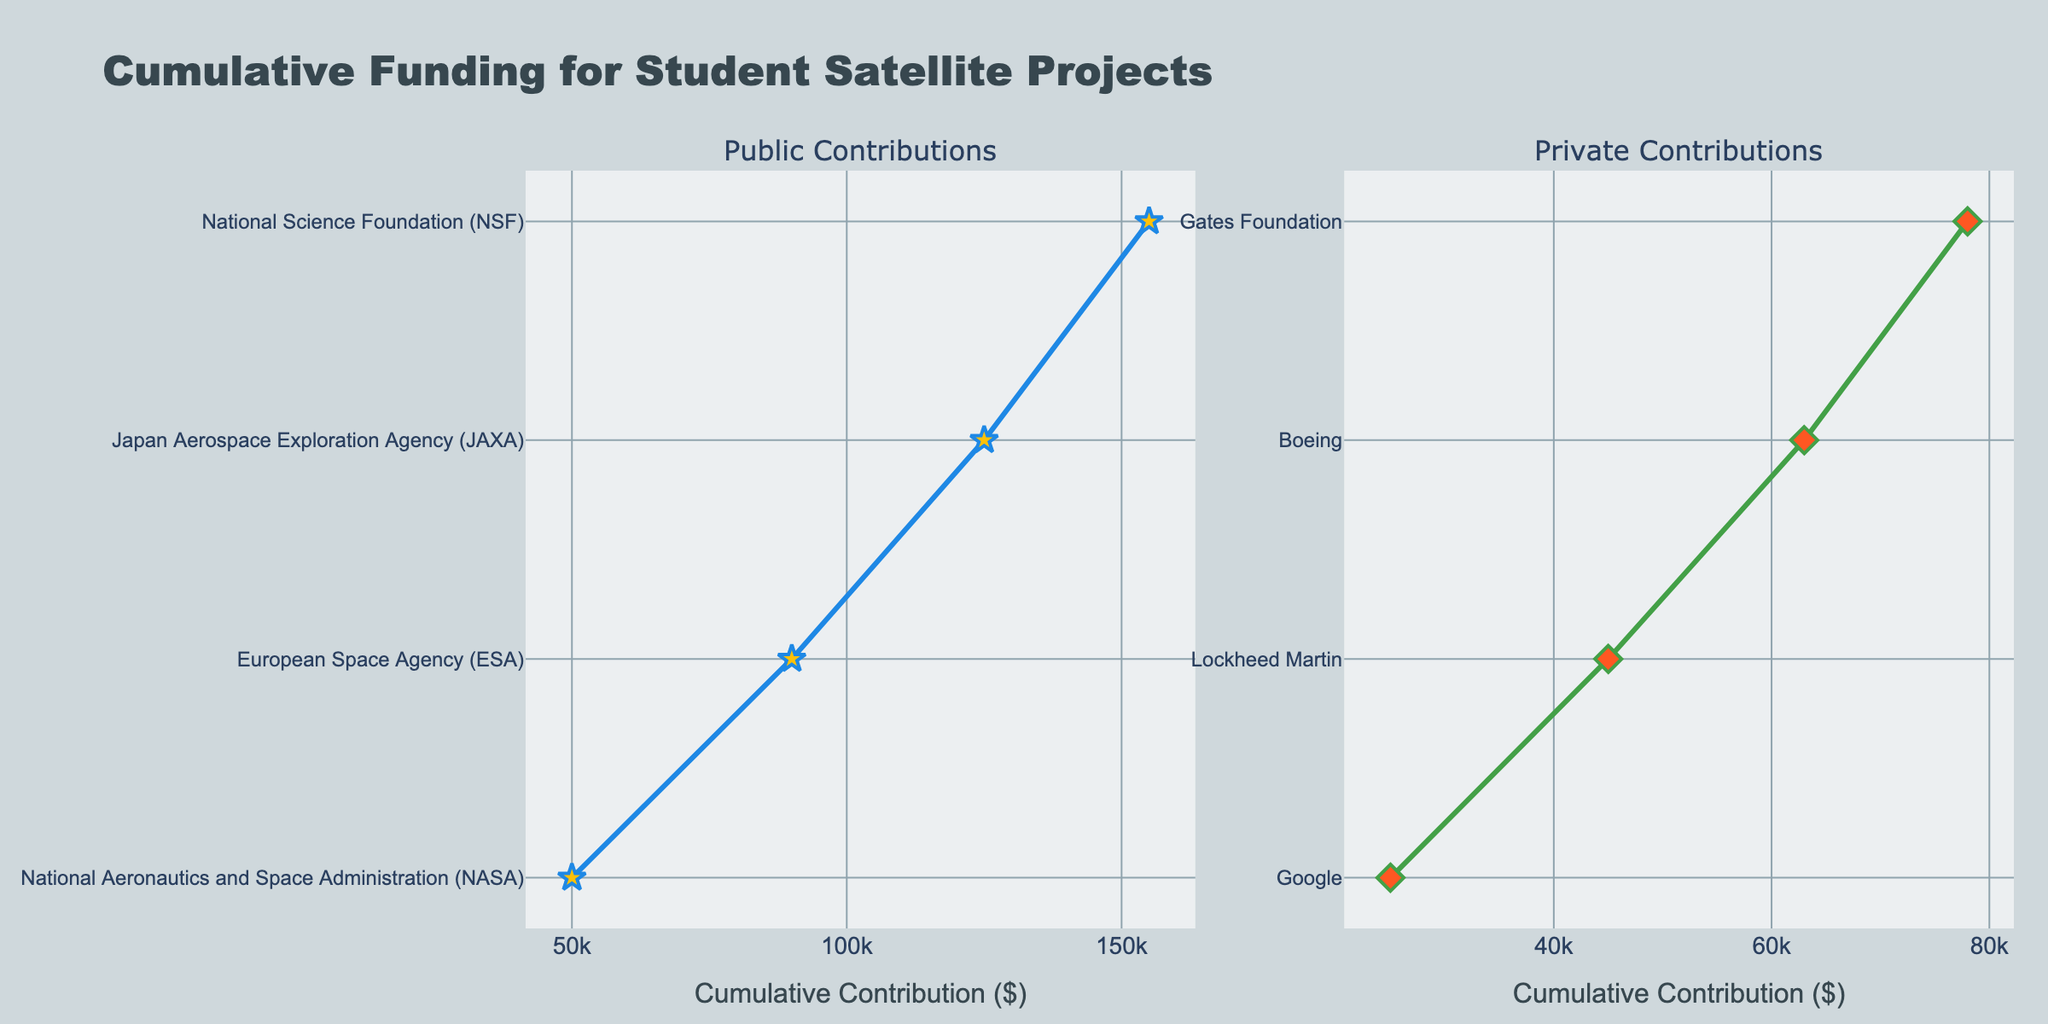What is the title of the figure? The title is located at the top of the plot and summarizes the content of the figure. In this case, it reads "Cumulative Funding for Student Satellite Projects".
Answer: Cumulative Funding for Student Satellite Projects What are the x-axis labels in the figure? The x-axis labels are indicated by the individual ticks at the bottom of the plot and represent the cumulative contribution in dollars ($). The label is "Cumulative Contribution ($)".
Answer: Cumulative Contribution ($) Which public source has the highest contribution and what is the amount? By looking at the left subplot under "Public Contributions", the source with the highest contribution is "National Aeronautics and Space Administration (NASA)", and the amount is represented by its position on the x-axis.
Answer: National Aeronautics and Space Administration (NASA), $50,000 What are the two colors representing the line plots for public and private contributions? The colors are evident from the line plots; the public contributions are shown in blue and the private contributions in green.
Answer: Blue for public, Green for private Which private source contributed the least and what is the amount? By examining the "Private Contributions" subplot on the right, the source with the least contribution is "Gates Foundation", and the amount is $15,000.
Answer: Gates Foundation, $15,000 What is the total cumulative contribution from the public category? Summing the cumulative contributions from all public sources, we add $50,000 (NASA), $40,000 (ESA), $35,000 (JAXA), and $30,000 (NSF). Therefore, the total is $50,000 + $40,000 + $35,000 + $30,000 = $155,000.
Answer: $155,000 Compare the cumulative contributions of NASA and Google. Which one is higher, and what is the difference in their contributions? NASA (public) contributes $50,000 and Google (private) contributes $25,000. By comparing the dollar amounts, NASA's contribution is higher. The difference is $50,000 - $25,000 = $25,000.
Answer: NASA by $25,000 What is the average contribution of private sources? Adding up all the private contributions: $15,000 (Gates Foundation) + $25,000 (Google) + $20,000 (Lockheed Martin) + $18,000 (Boeing) = $78,000. Then divide by the number of private sources, which is 4. The average contribution is $78,000 / 4 = $19,500.
Answer: $19,500 Which public and private sources have the closest contribution amounts, and what is their contribution? Inspecting the figure, we see that JAXA (public) has a contribution of $35,000 and Lockheed Martin (private) has a contribution of $20,000. JAXA has the closest higher value, so this is our pair with their contribution amounts represented in the figure.
Answer: JAXA and Lockheed Martin, $35,000 and $20,000 respectively 